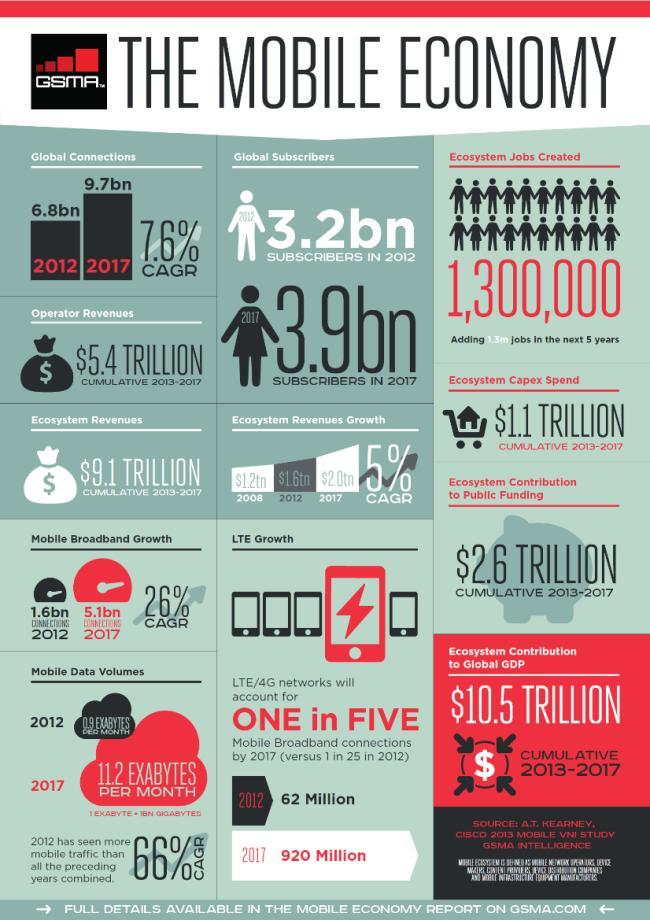How many global subscribers were there in 2017?
Answer the question with a short phrase. 3.9bn What was the ecosystem revenues growth in 2012? $1.6tn How many broadband connections were there in 2017? 5.1bn 